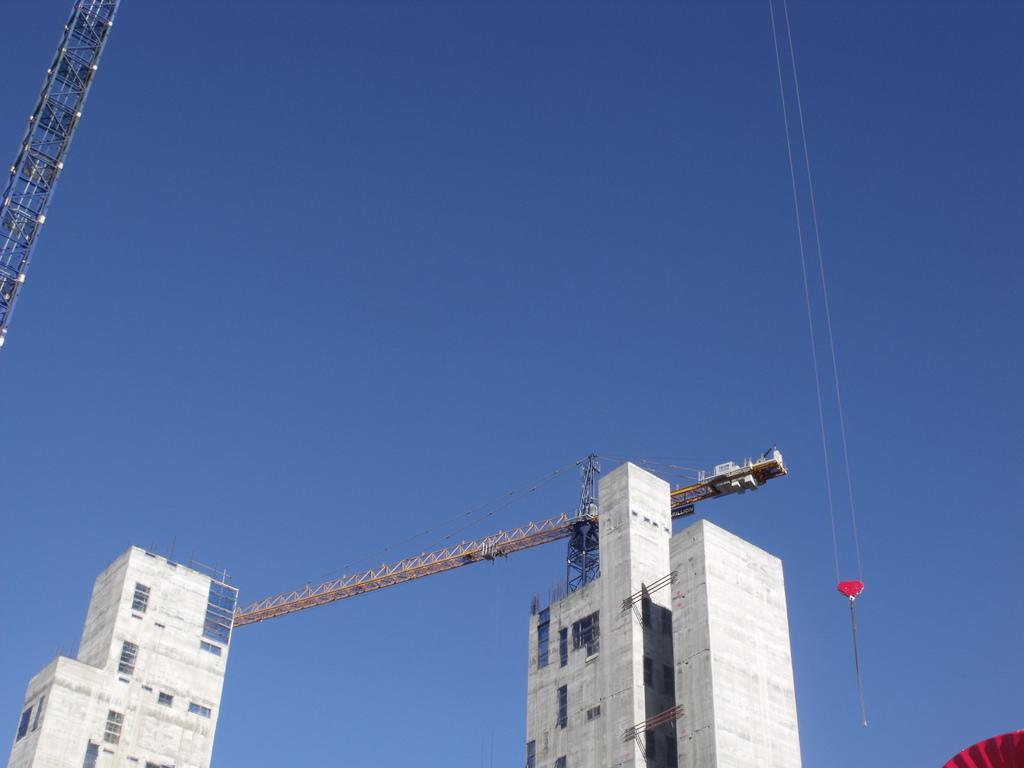What type of structures can be seen in the image? There are buildings in the image. What feature is present on the buildings? There are windows in the image. What construction equipment is visible in the image? There are cranes in the image. What color is the sky in the image? The sky is blue in the image. Can you see a yak grazing in the image? There is no yak present in the image. What stage of development is the construction project in the image? The image does not provide information about the stage of development of the construction project. 